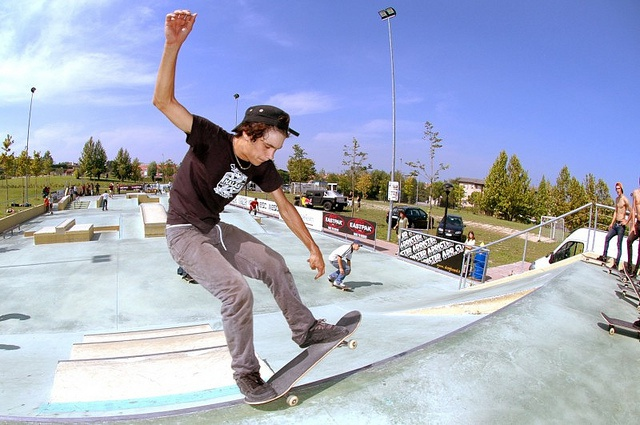Describe the objects in this image and their specific colors. I can see people in lightblue, black, darkgray, and gray tones, skateboard in lightblue, gray, and lightgray tones, people in lightblue, black, darkgray, gray, and olive tones, people in lightblue, tan, black, gray, and brown tones, and people in lightblue, black, white, maroon, and salmon tones in this image. 